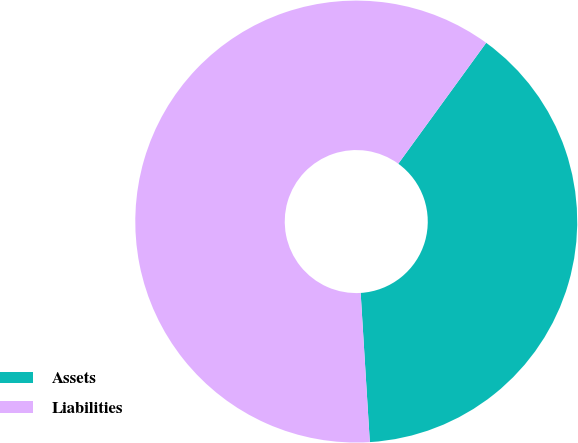Convert chart to OTSL. <chart><loc_0><loc_0><loc_500><loc_500><pie_chart><fcel>Assets<fcel>Liabilities<nl><fcel>39.02%<fcel>60.98%<nl></chart> 